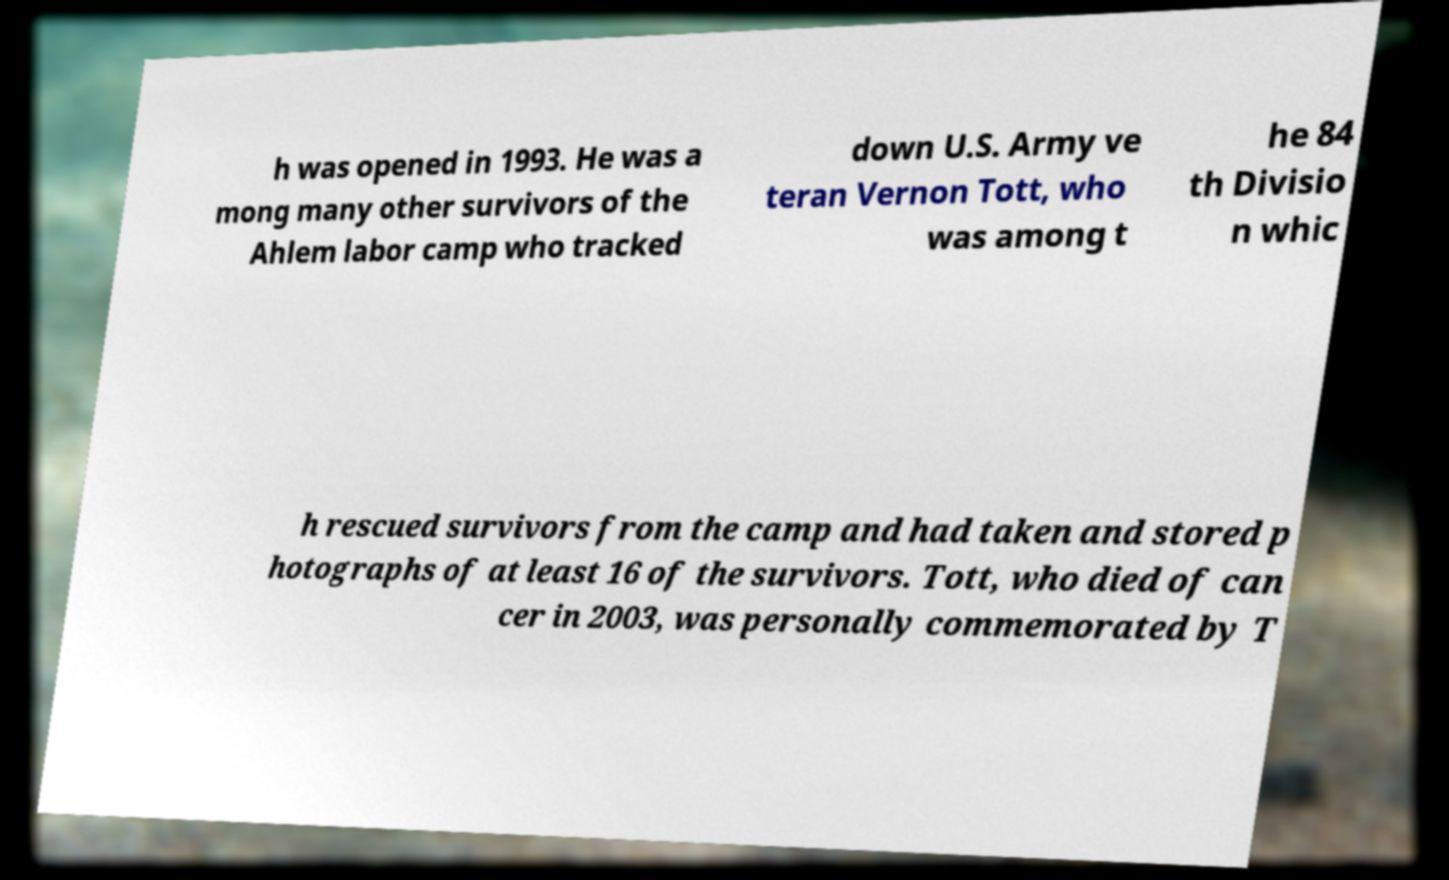Please identify and transcribe the text found in this image. h was opened in 1993. He was a mong many other survivors of the Ahlem labor camp who tracked down U.S. Army ve teran Vernon Tott, who was among t he 84 th Divisio n whic h rescued survivors from the camp and had taken and stored p hotographs of at least 16 of the survivors. Tott, who died of can cer in 2003, was personally commemorated by T 